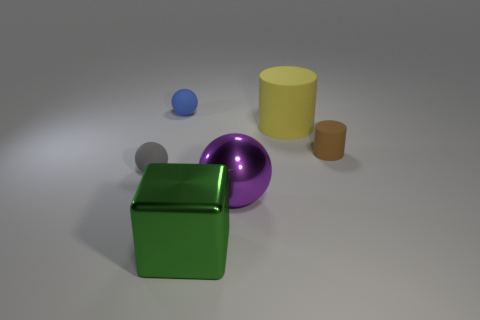Are there more large green metallic things on the left side of the small gray object than small blue matte balls on the right side of the green shiny cube?
Your answer should be compact. No. The object that is made of the same material as the purple ball is what shape?
Make the answer very short. Cube. How many other things are the same shape as the big yellow object?
Your answer should be compact. 1. The big metal object in front of the metal ball has what shape?
Make the answer very short. Cube. The tiny cylinder has what color?
Your response must be concise. Brown. What number of other objects are there of the same size as the brown cylinder?
Keep it short and to the point. 2. There is a big thing to the left of the large shiny object that is to the right of the green metal thing; what is its material?
Your answer should be very brief. Metal. Do the gray matte thing and the cylinder that is to the right of the big matte cylinder have the same size?
Your response must be concise. Yes. Are there any objects that have the same color as the large metal block?
Your answer should be very brief. No. How many tiny things are either brown metallic objects or blocks?
Make the answer very short. 0. 